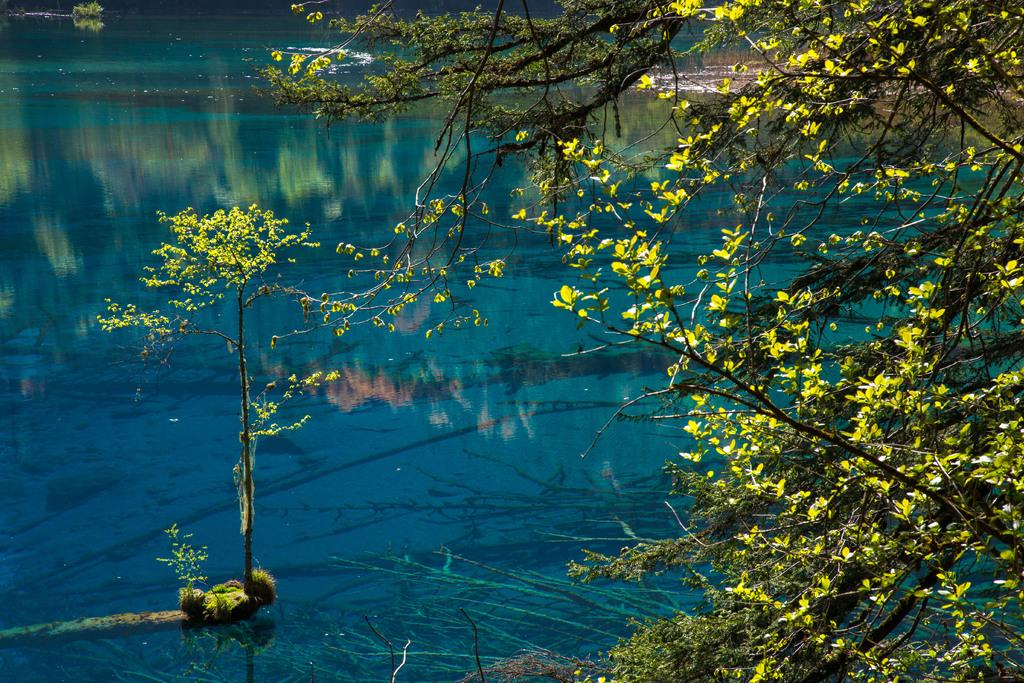What type of vegetation can be seen on the trees in the image? There are flowers on the trees in the image. What object is present in the image besides the trees? There is a pot in the image. Can you see a bridge in the image? No, there is no bridge present in the image. Is there a boy helping with the flowers in the image? No, there is no boy present in the image. 